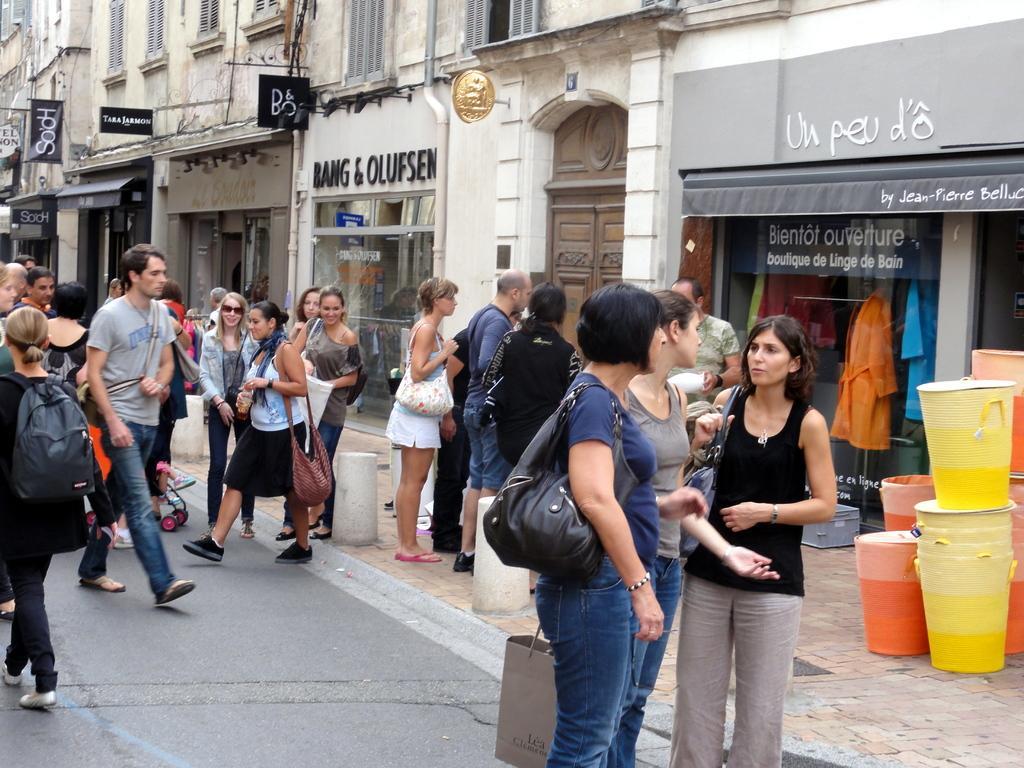In one or two sentences, can you explain what this image depicts? In this picture I can see buildings and I can see few people are standing and walking and I can see few baskets on the sidewalk and I can see text on the walls and I can see few boards with some text. 